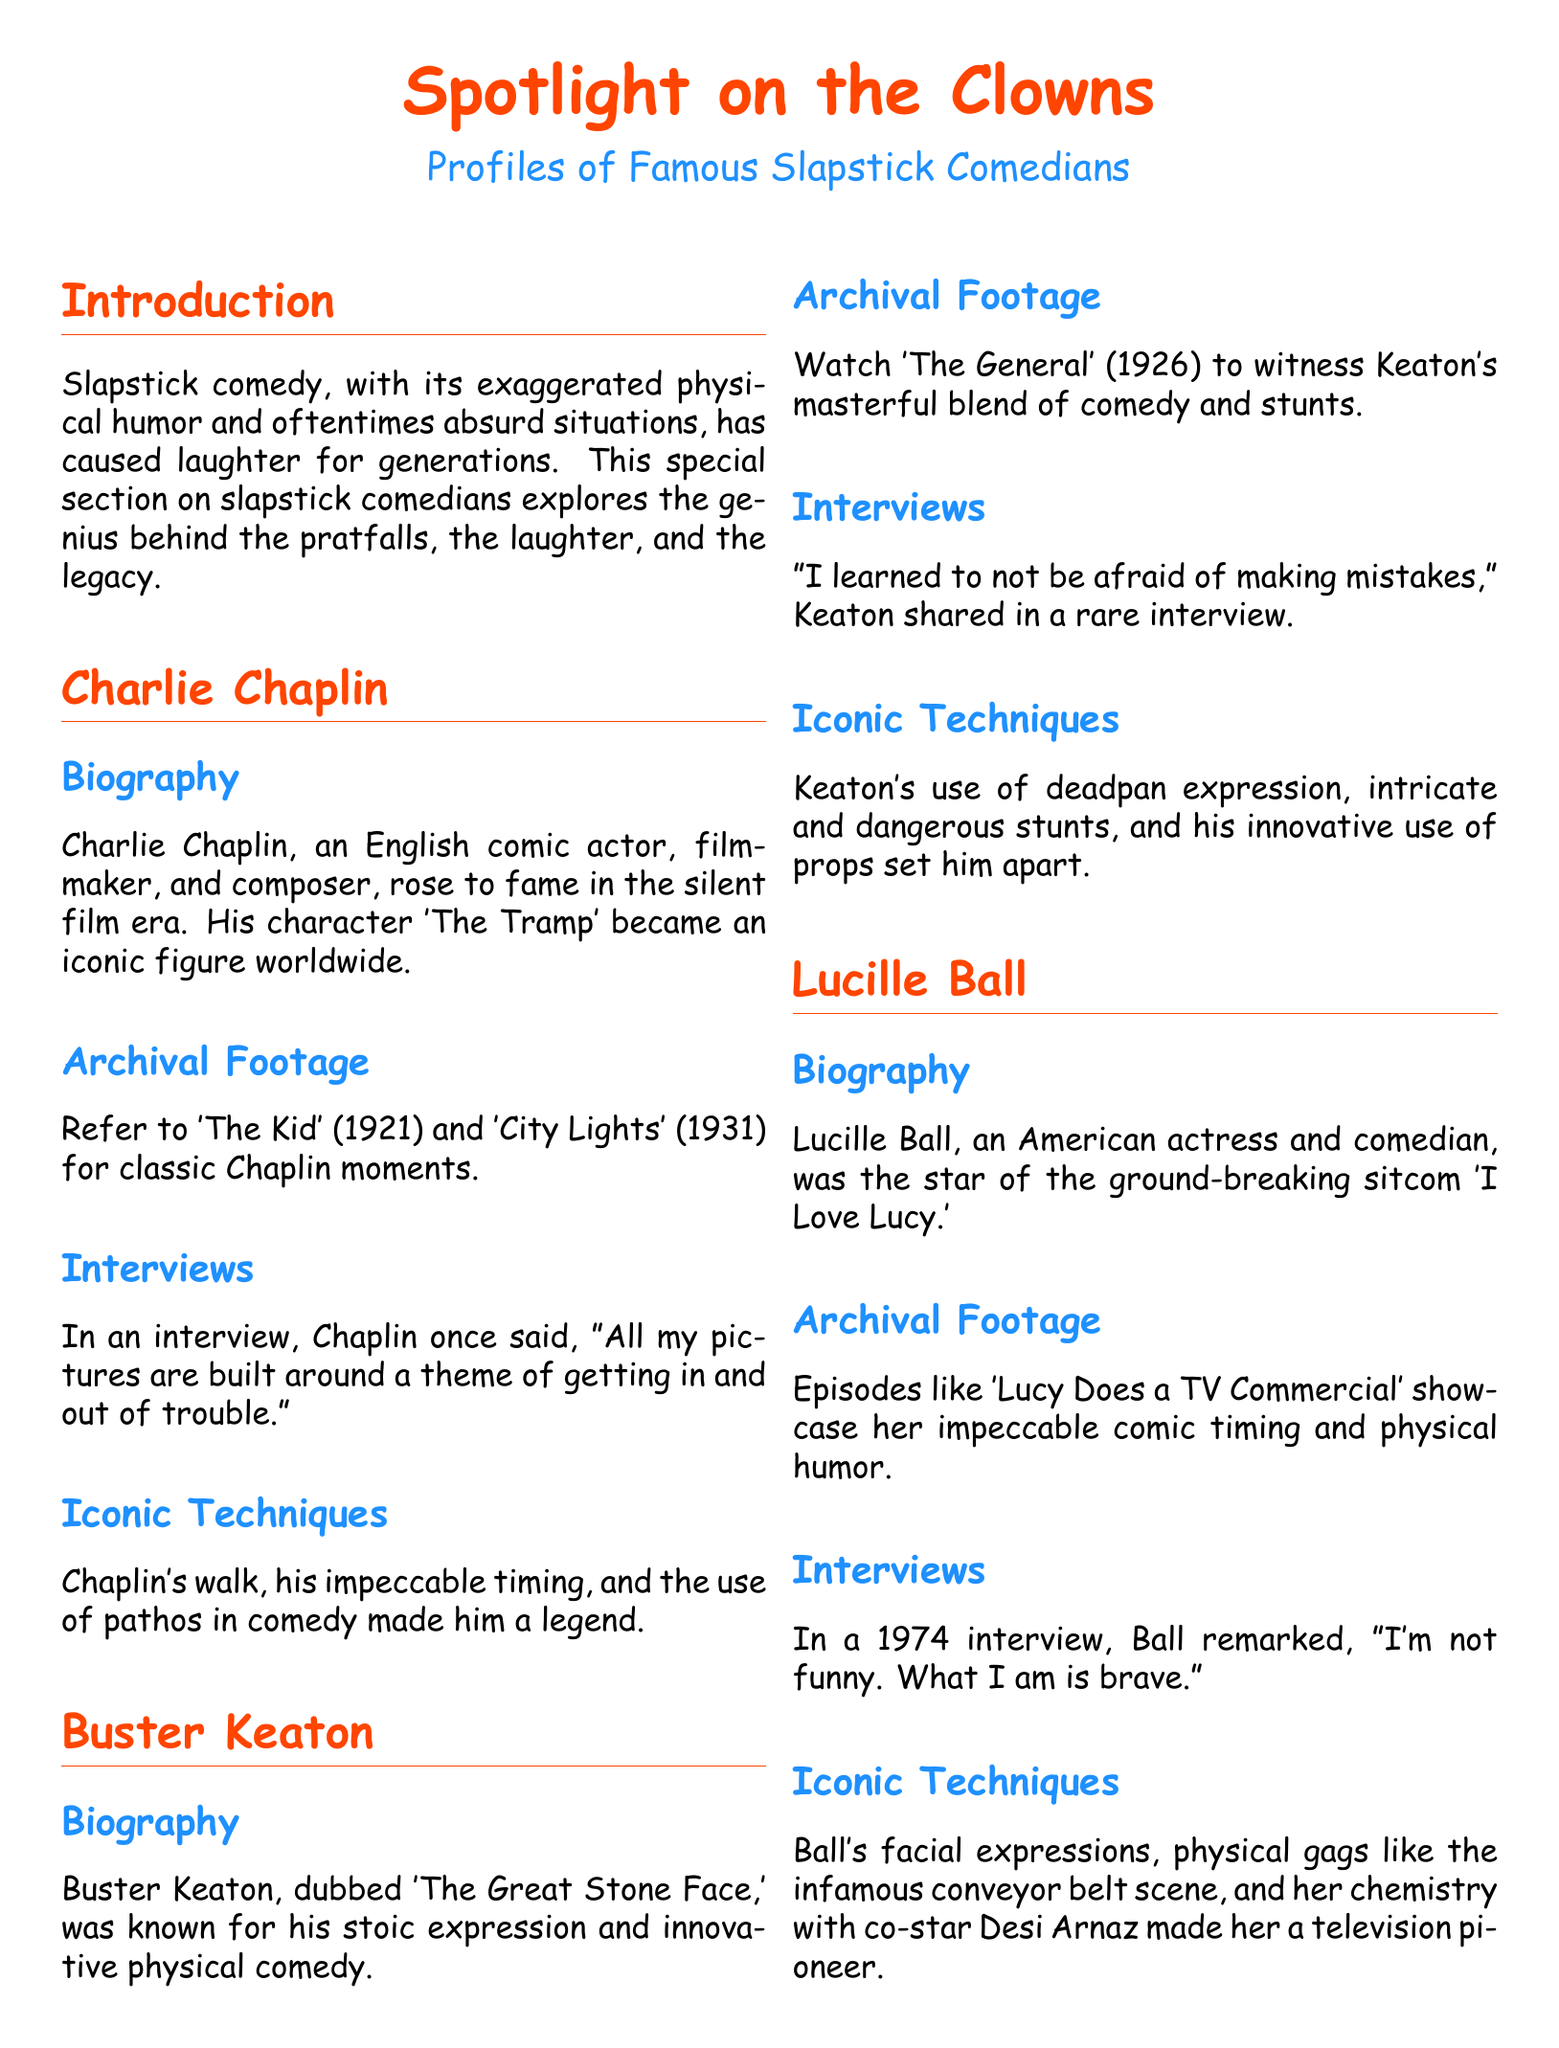What is the title of the document? The title is presented prominently at the top of the document, which is "Spotlight on the Clowns."
Answer: Spotlight on the Clowns Who is the editor listed at the end of the document? The document names John Doe as the editor in the closing section.
Answer: John Doe Which silent film features Charlie Chaplin? The document lists 'The Kid' and 'City Lights' as classic films featuring Charlie Chaplin.
Answer: The Kid, City Lights What unique characteristic is Buster Keaton known for? Buster Keaton is referred to as 'The Great Stone Face,' highlighting his stoic expression.
Answer: The Great Stone Face What sitcom did Lucille Ball star in? The document mentions that Lucille Ball starred in the groundbreaking sitcom 'I Love Lucy.'
Answer: I Love Lucy How does Lucille Ball describe her comedic talent in her interview? The document quotes Lucille Ball saying, "I'm not funny. What I am is brave." indicating her perception of bravery in comedy.
Answer: Brave What year did 'The General' release? The document specifies that 'The General' was released in 1926.
Answer: 1926 What are the colors used for titles in the document? The document employs spotlight red for sections and comedy blue for subsections, as specified in the formatting.
Answer: Spotlight red and comedy blue How are the profiles structured in the document? Each comedian's profile includes sections on biography, archival footage, interviews, and iconic techniques.
Answer: Biography, Archival Footage, Interviews, Iconic Techniques 